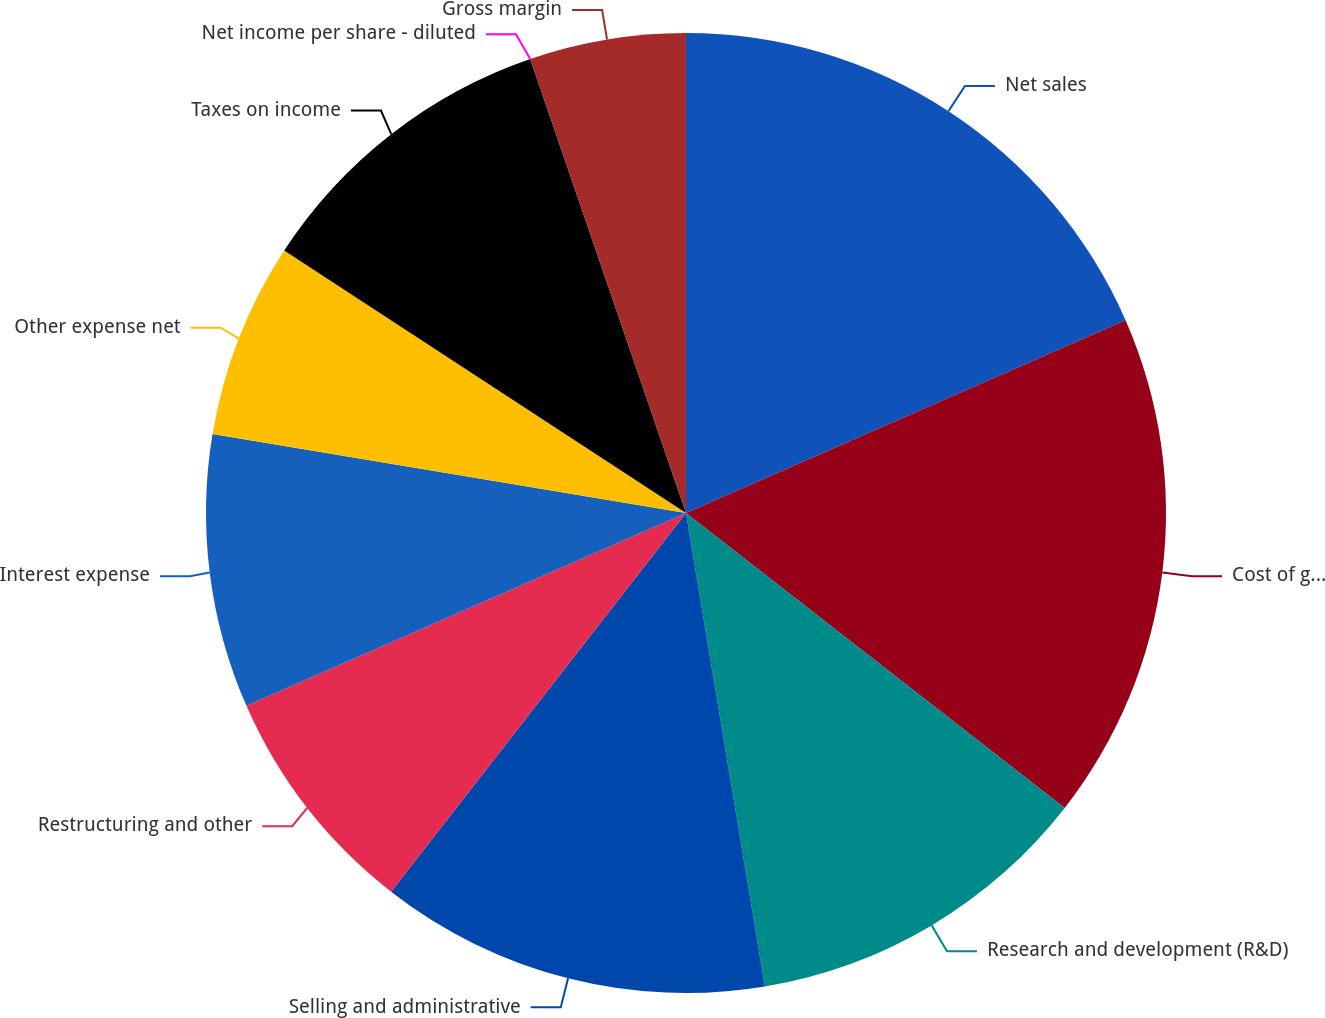<chart> <loc_0><loc_0><loc_500><loc_500><pie_chart><fcel>Net sales<fcel>Cost of goods sold<fcel>Research and development (R&D)<fcel>Selling and administrative<fcel>Restructuring and other<fcel>Interest expense<fcel>Other expense net<fcel>Taxes on income<fcel>Net income per share - diluted<fcel>Gross margin<nl><fcel>18.42%<fcel>17.11%<fcel>11.84%<fcel>13.16%<fcel>7.89%<fcel>9.21%<fcel>6.58%<fcel>10.53%<fcel>0.0%<fcel>5.26%<nl></chart> 